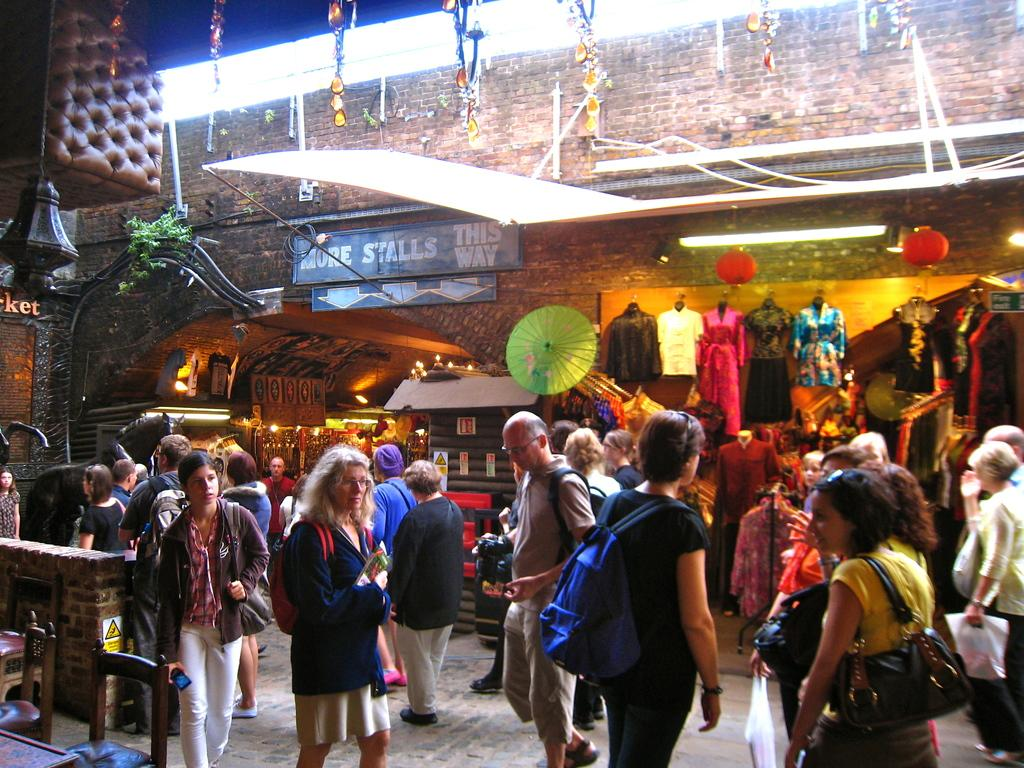What is happening on the road in the image? There are many people standing on the road in the image. What can be seen in the background of the image? There are stalls and a wall with clothes hanging on it in the background of the image. What is the surface that the people are standing on? There is a floor visible at the bottom of the image. How many cats are visible in the image? There are no cats present in the image. Is there a visitor in the image? The term "visitor" is not mentioned in the provided facts, so it cannot be determined if there is a visitor in the image. 